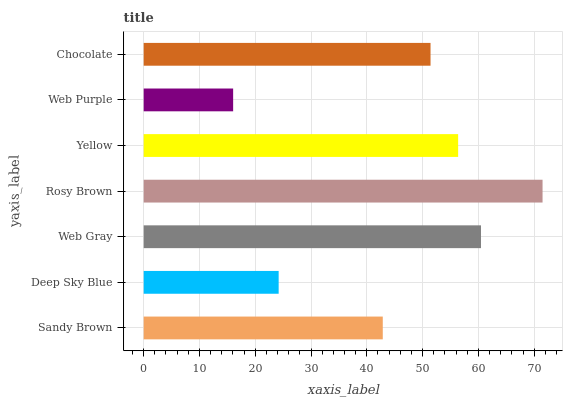Is Web Purple the minimum?
Answer yes or no. Yes. Is Rosy Brown the maximum?
Answer yes or no. Yes. Is Deep Sky Blue the minimum?
Answer yes or no. No. Is Deep Sky Blue the maximum?
Answer yes or no. No. Is Sandy Brown greater than Deep Sky Blue?
Answer yes or no. Yes. Is Deep Sky Blue less than Sandy Brown?
Answer yes or no. Yes. Is Deep Sky Blue greater than Sandy Brown?
Answer yes or no. No. Is Sandy Brown less than Deep Sky Blue?
Answer yes or no. No. Is Chocolate the high median?
Answer yes or no. Yes. Is Chocolate the low median?
Answer yes or no. Yes. Is Sandy Brown the high median?
Answer yes or no. No. Is Deep Sky Blue the low median?
Answer yes or no. No. 